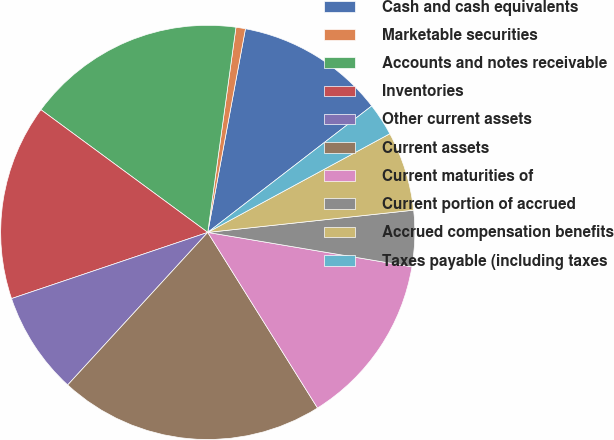Convert chart to OTSL. <chart><loc_0><loc_0><loc_500><loc_500><pie_chart><fcel>Cash and cash equivalents<fcel>Marketable securities<fcel>Accounts and notes receivable<fcel>Inventories<fcel>Other current assets<fcel>Current assets<fcel>Current maturities of<fcel>Current portion of accrued<fcel>Accrued compensation benefits<fcel>Taxes payable (including taxes<nl><fcel>11.63%<fcel>0.74%<fcel>17.08%<fcel>15.27%<fcel>8.0%<fcel>20.71%<fcel>13.45%<fcel>4.37%<fcel>6.19%<fcel>2.55%<nl></chart> 